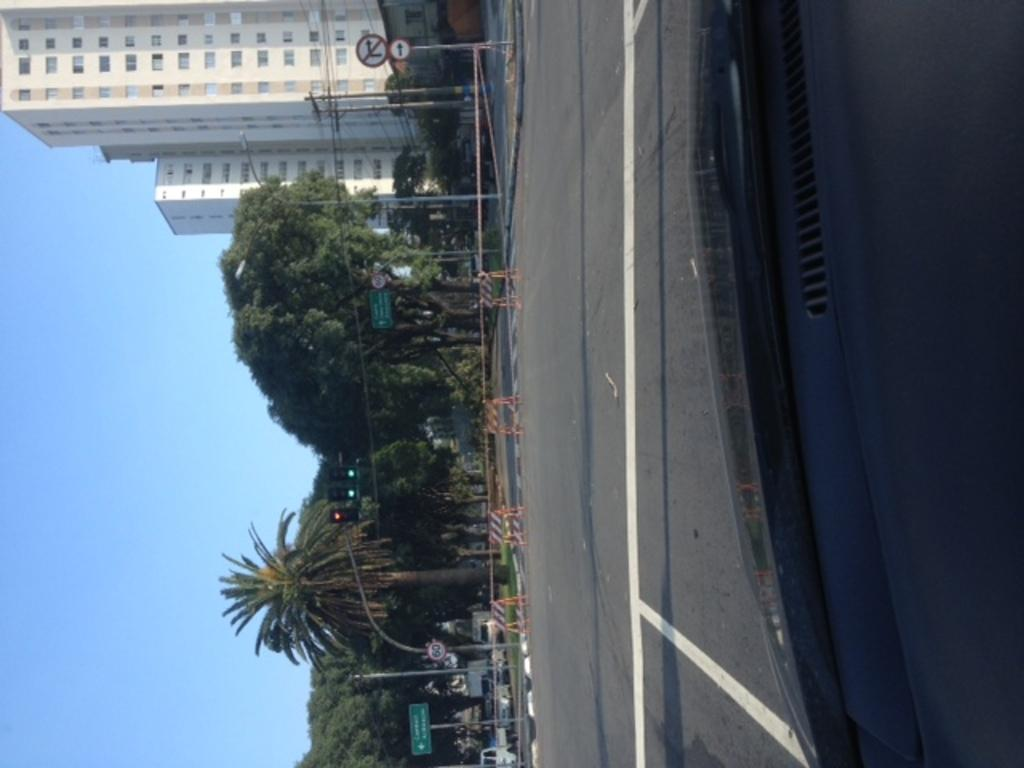What type of natural elements can be seen in the image? There are trees in the image. What type of man-made structures can be seen in the image? There are buildings, poles, street lights, and a sign board in the image. What might be used to control traffic in the image? There are barricades in the image. What type of transportation can be seen in the image? There are vehicles on the road in the image. What is visible at the top of the image? The sky is visible at the top of the image. What type of form or design can be seen on the vehicles in the image? The provided facts do not mention any specific form or design on the vehicles, so we cannot answer this question based on the information given. What type of experience can be gained from observing the image? The provided facts do not mention any specific experience that can be gained from observing the image, so we cannot answer this question based on the information given. 